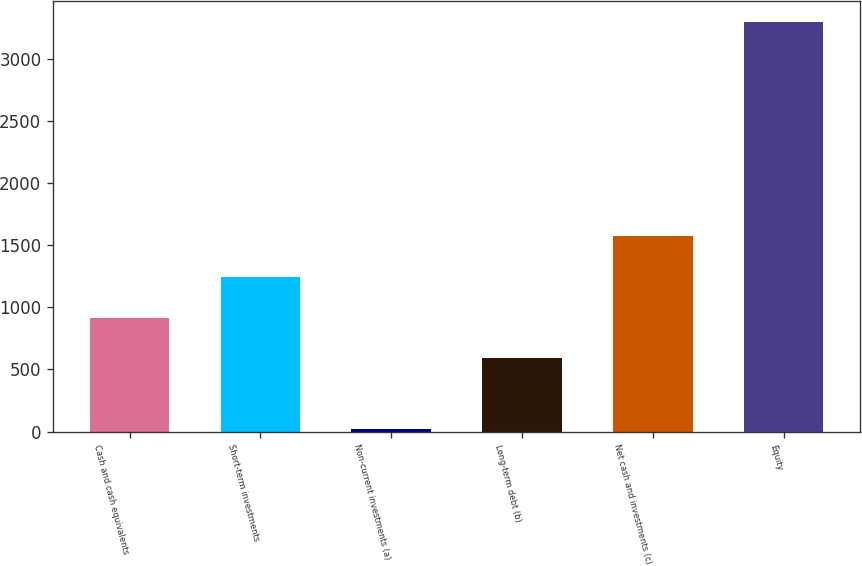Convert chart. <chart><loc_0><loc_0><loc_500><loc_500><bar_chart><fcel>Cash and cash equivalents<fcel>Short-term investments<fcel>Non-current investments (a)<fcel>Long-term debt (b)<fcel>Net cash and investments (c)<fcel>Equity<nl><fcel>916.02<fcel>1243.84<fcel>21.4<fcel>588.2<fcel>1571.66<fcel>3299.6<nl></chart> 